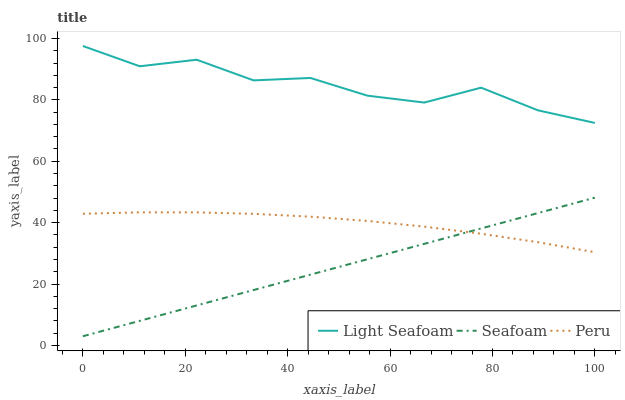Does Seafoam have the minimum area under the curve?
Answer yes or no. Yes. Does Light Seafoam have the maximum area under the curve?
Answer yes or no. Yes. Does Peru have the minimum area under the curve?
Answer yes or no. No. Does Peru have the maximum area under the curve?
Answer yes or no. No. Is Seafoam the smoothest?
Answer yes or no. Yes. Is Light Seafoam the roughest?
Answer yes or no. Yes. Is Peru the smoothest?
Answer yes or no. No. Is Peru the roughest?
Answer yes or no. No. Does Peru have the lowest value?
Answer yes or no. No. Does Light Seafoam have the highest value?
Answer yes or no. Yes. Does Seafoam have the highest value?
Answer yes or no. No. Is Peru less than Light Seafoam?
Answer yes or no. Yes. Is Light Seafoam greater than Seafoam?
Answer yes or no. Yes. Does Peru intersect Light Seafoam?
Answer yes or no. No. 